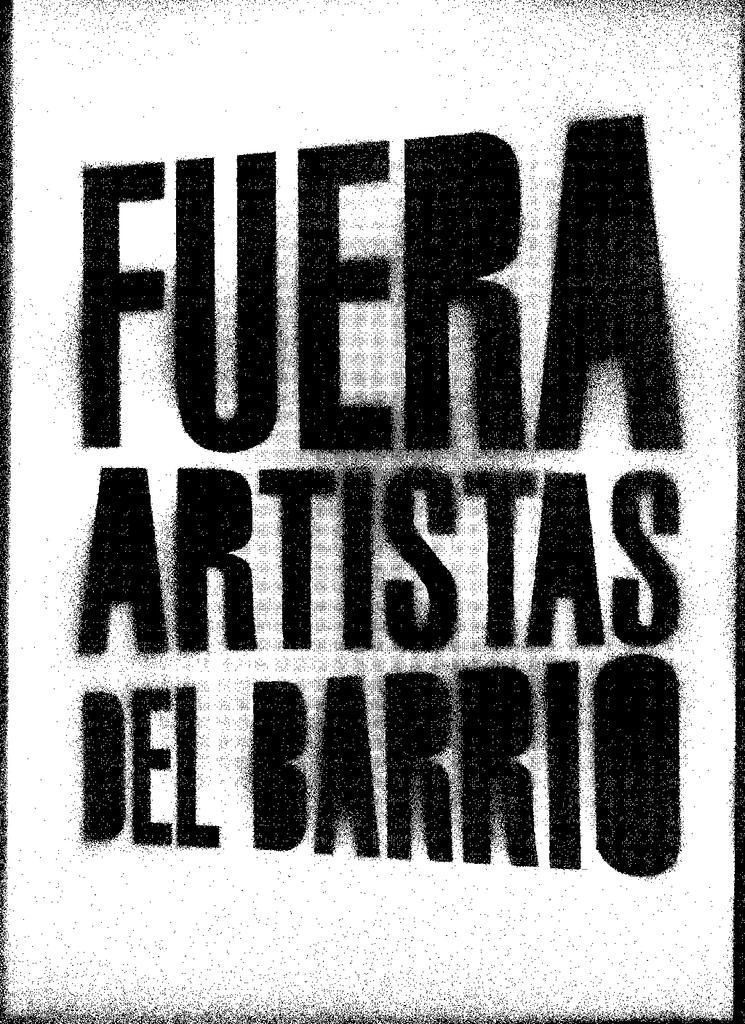<image>
Create a compact narrative representing the image presented. A sign that says Fuera Artistas del Barrio. 